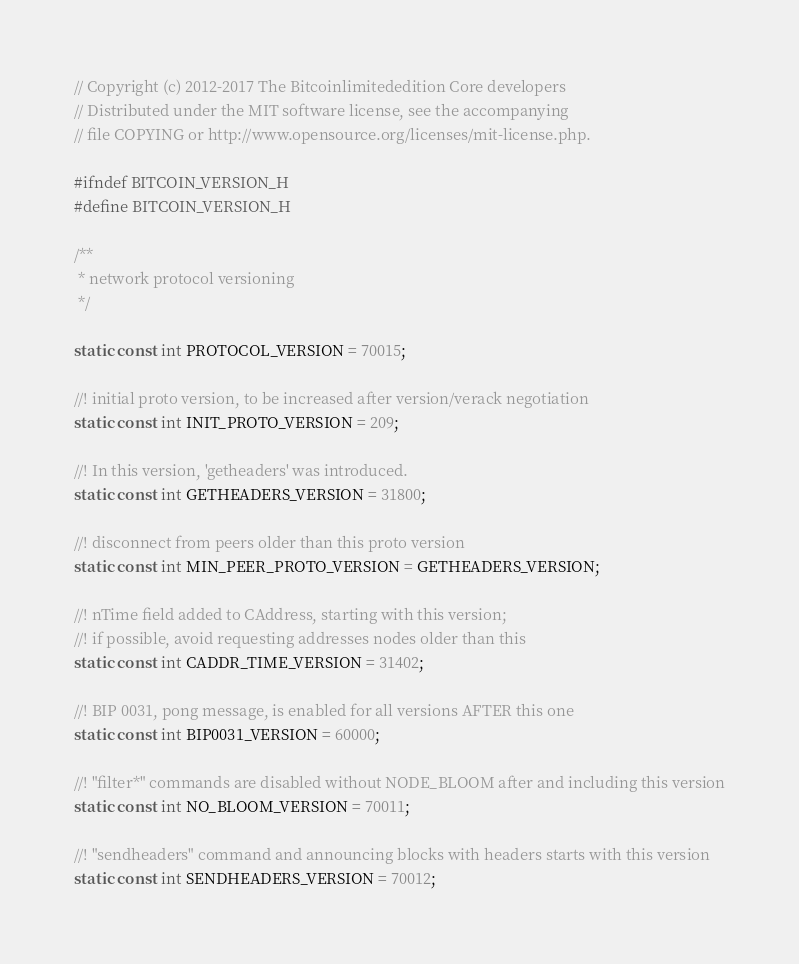Convert code to text. <code><loc_0><loc_0><loc_500><loc_500><_C_>// Copyright (c) 2012-2017 The Bitcoinlimitededition Core developers
// Distributed under the MIT software license, see the accompanying
// file COPYING or http://www.opensource.org/licenses/mit-license.php.

#ifndef BITCOIN_VERSION_H
#define BITCOIN_VERSION_H

/**
 * network protocol versioning
 */

static const int PROTOCOL_VERSION = 70015;

//! initial proto version, to be increased after version/verack negotiation
static const int INIT_PROTO_VERSION = 209;

//! In this version, 'getheaders' was introduced.
static const int GETHEADERS_VERSION = 31800;

//! disconnect from peers older than this proto version
static const int MIN_PEER_PROTO_VERSION = GETHEADERS_VERSION;

//! nTime field added to CAddress, starting with this version;
//! if possible, avoid requesting addresses nodes older than this
static const int CADDR_TIME_VERSION = 31402;

//! BIP 0031, pong message, is enabled for all versions AFTER this one
static const int BIP0031_VERSION = 60000;

//! "filter*" commands are disabled without NODE_BLOOM after and including this version
static const int NO_BLOOM_VERSION = 70011;

//! "sendheaders" command and announcing blocks with headers starts with this version
static const int SENDHEADERS_VERSION = 70012;
</code> 